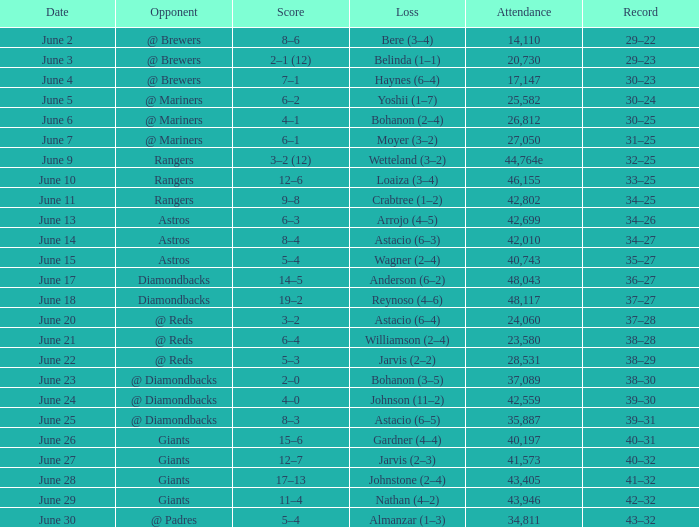What's the record when the attendance was 28,531? 38–29. 